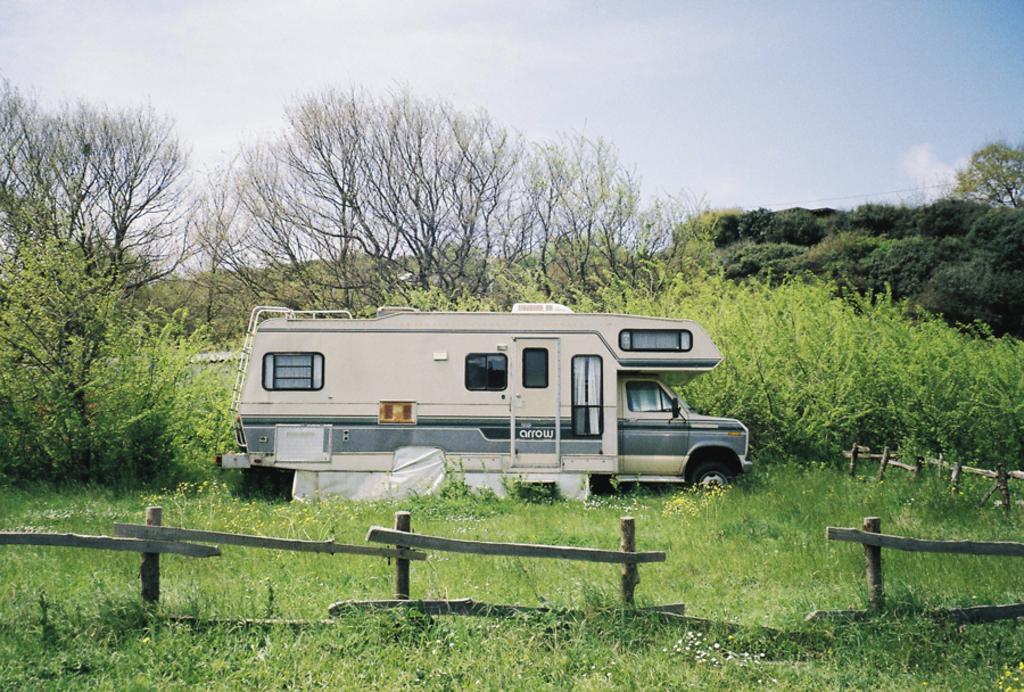How would you summarize this image in a sentence or two? In the center of the image we can see a truck on the ground. We can also see some grass, plants with flowers, the wooden fence, a group of trees and the sky which looks cloudy. 